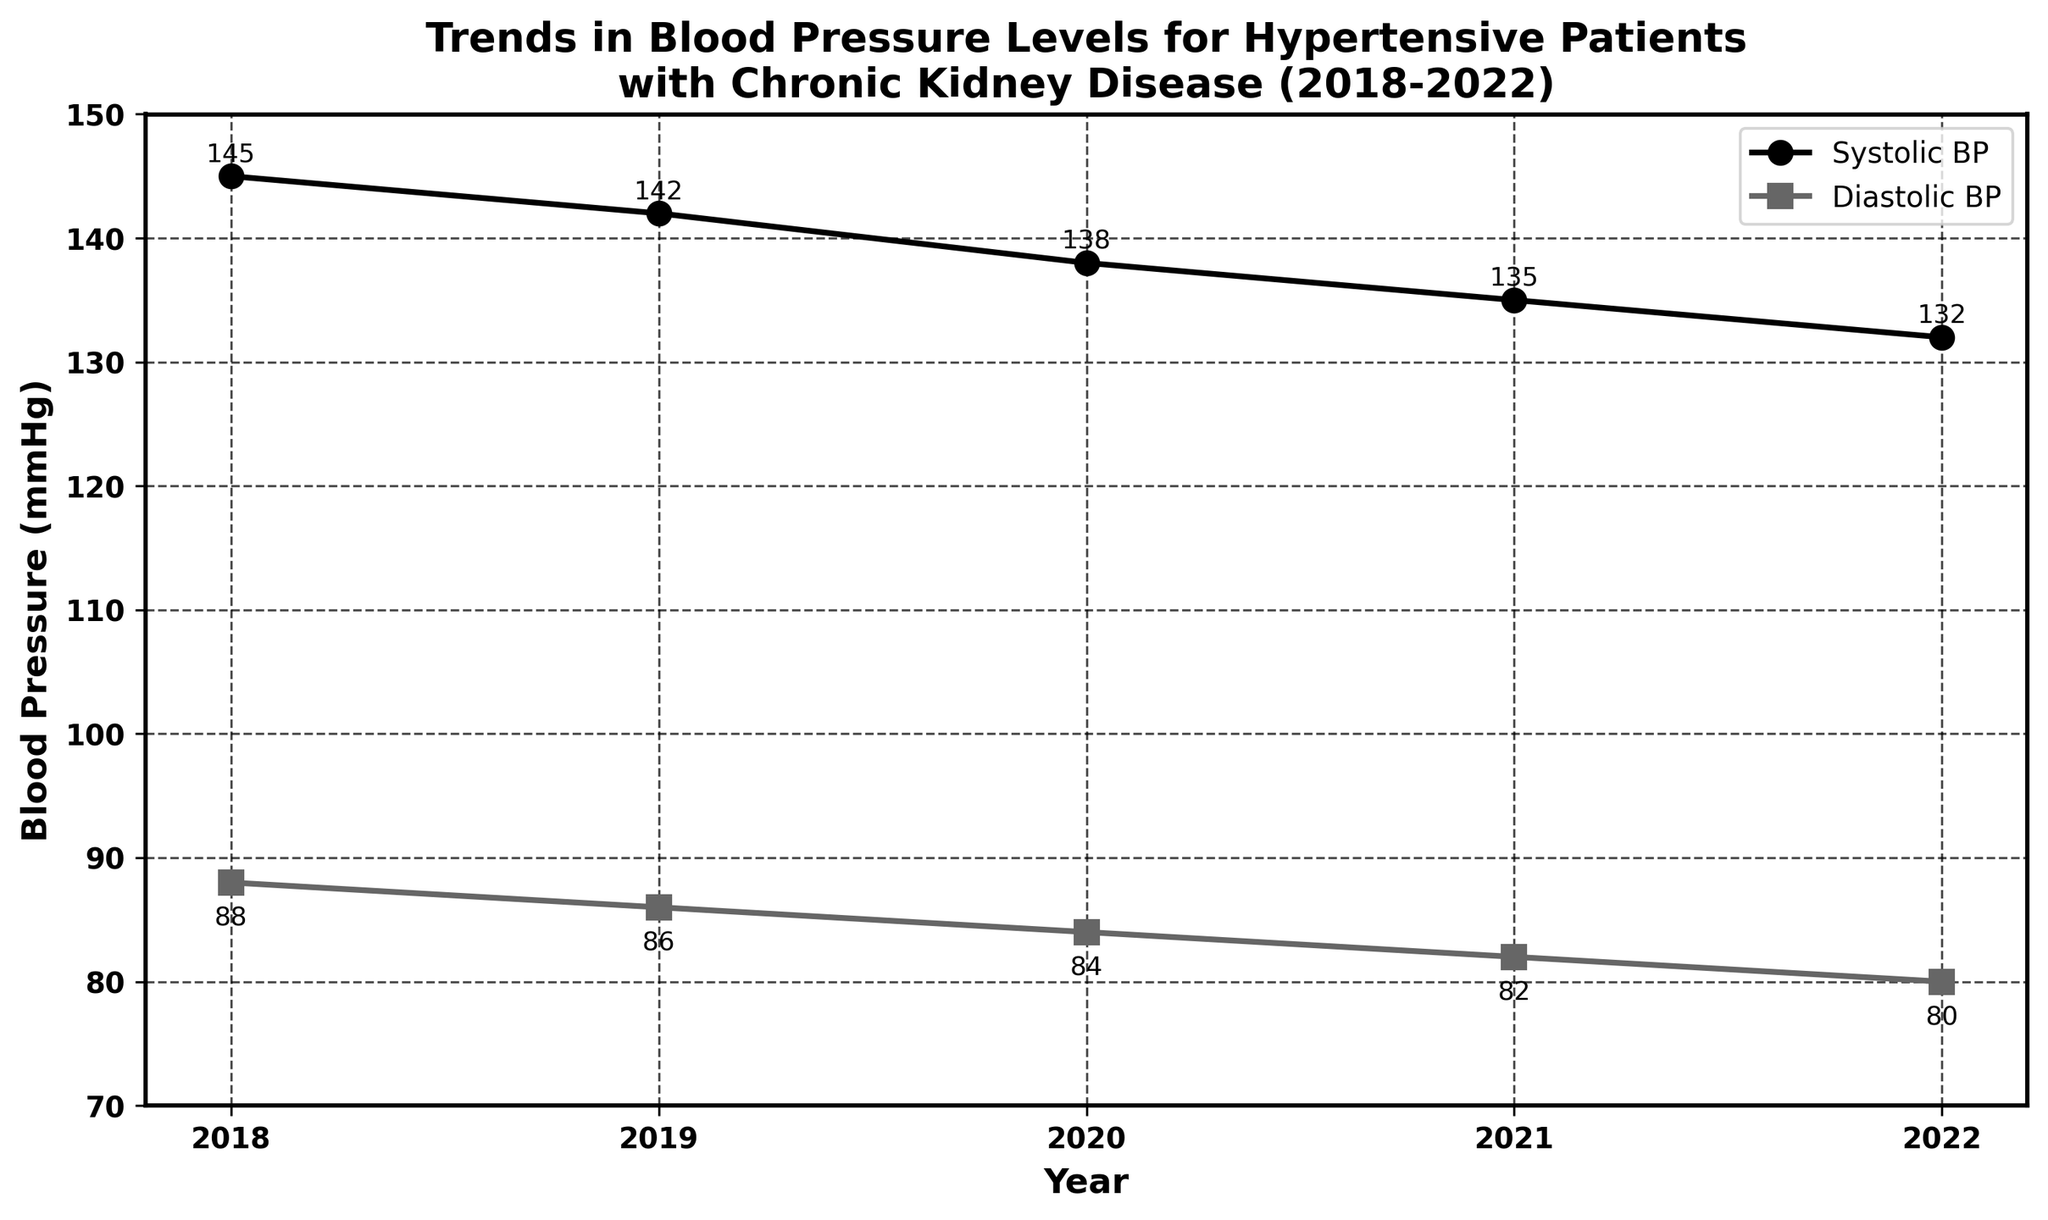What is the overall trend in systolic blood pressure from 2018 to 2022? The systolic blood pressure shows a decreasing trend over the years. From the figure, it can be seen that the systolic BP decreased from 145 mmHg in 2018 to 132 mmHg in 2022.
Answer: Decreasing How much did the average diastolic blood pressure decrease from 2018 to 2022? To find the decrease, subtract the diastolic BP in 2022 from the diastolic BP in 2018. From the figure, 88 mmHg (2018) - 80 mmHg (2022) = 8 mmHg.
Answer: 8 mmHg In which year was the difference between systolic and diastolic blood pressure the greatest? To find the year with the greatest difference, calculate the differences for each year: 2018 (145-88=57), 2019 (142-86=56), 2020 (138-84=54), 2021 (135-82=53), 2022 (132-80=52). The greatest difference is 57 in 2018.
Answer: 2018 What’s the average systolic blood pressure over the 5-year period? Add the systolic BP values and divide by the number of years: (145 + 142 + 138 + 135 + 132) / 5. This gives (692) / 5 = 138.4 mmHg.
Answer: 138.4 mmHg During which year did the systolic blood pressure experience the largest decrease compared to the previous year? Calculate the yearly differences: 2019-2018 (142-145=-3), 2020-2019 (138-142=-4), 2021-2020 (135-138=-3), 2022-2021 (132-135=-3). The largest decrease is -4 mmHg in 2020 compared to 2019.
Answer: 2020 Is the gap between systolic and diastolic blood pressure higher in 2021 or 2022? Calculate the gaps: 2021 (135-82=53), 2022 (132-80=52). The gap in 2021 is higher.
Answer: 2021 What is the visual characteristic of the data points representing diastolic blood pressure? The diastolic BP data points are depicted as squares, different from the circular data points of systolic BP.
Answer: Squares By how much did the systolic blood pressure decrease on average each year? Total decrease from 2018 to 2022 is 145-132=13 mmHg over 4 years. Average yearly decrease: 13 / 4 = 3.25 mmHg.
Answer: 3.25 mmHg How does the decreasing trend compare between systolic and diastolic blood pressure over the 5 years? Both systolic and diastolic pressures show a decreasing trend over 5 years. Systolic BP decreases steadily from 145 mmHg to 132 mmHg, while diastolic BP decreases from 88 mmHg to 80 mmHg.
Answer: Both decrease 